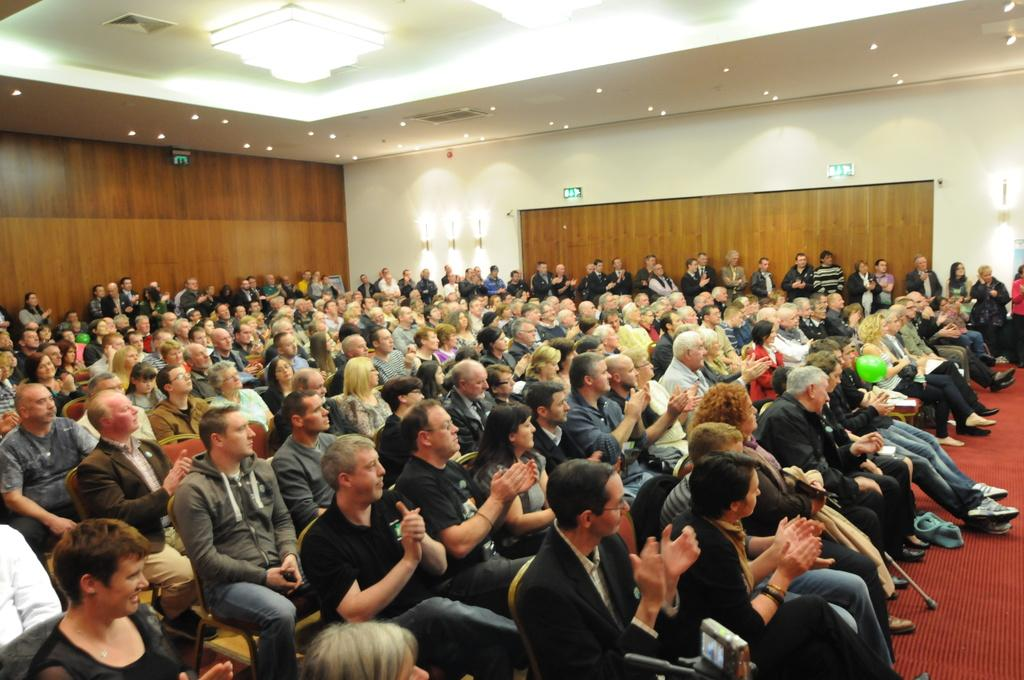What is happening in the image involving a group of people? In the image, there is a group of people sitting on chairs. Can you describe the setting where the people are sitting? There is a wooden wall visible in the image, and lights are present. What is the color of the wooden wall? The wooden wall is in white color. What type of whip can be seen in the hands of the people in the image? There is no whip present in the image; the people are sitting on chairs and there is no indication of any whip. 